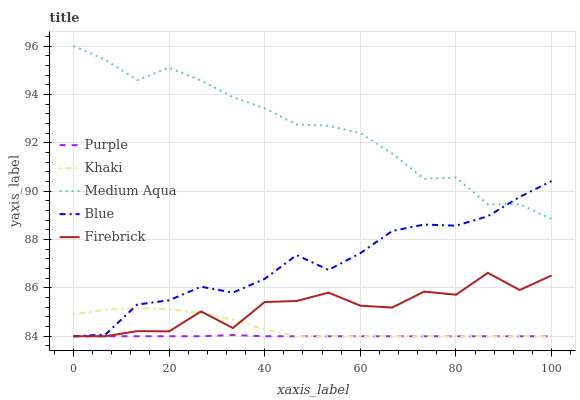Does Purple have the minimum area under the curve?
Answer yes or no. Yes. Does Medium Aqua have the maximum area under the curve?
Answer yes or no. Yes. Does Blue have the minimum area under the curve?
Answer yes or no. No. Does Blue have the maximum area under the curve?
Answer yes or no. No. Is Purple the smoothest?
Answer yes or no. Yes. Is Firebrick the roughest?
Answer yes or no. Yes. Is Blue the smoothest?
Answer yes or no. No. Is Blue the roughest?
Answer yes or no. No. Does Medium Aqua have the lowest value?
Answer yes or no. No. Does Medium Aqua have the highest value?
Answer yes or no. Yes. Does Blue have the highest value?
Answer yes or no. No. Is Khaki less than Medium Aqua?
Answer yes or no. Yes. Is Medium Aqua greater than Purple?
Answer yes or no. Yes. Does Khaki intersect Firebrick?
Answer yes or no. Yes. Is Khaki less than Firebrick?
Answer yes or no. No. Is Khaki greater than Firebrick?
Answer yes or no. No. Does Khaki intersect Medium Aqua?
Answer yes or no. No. 